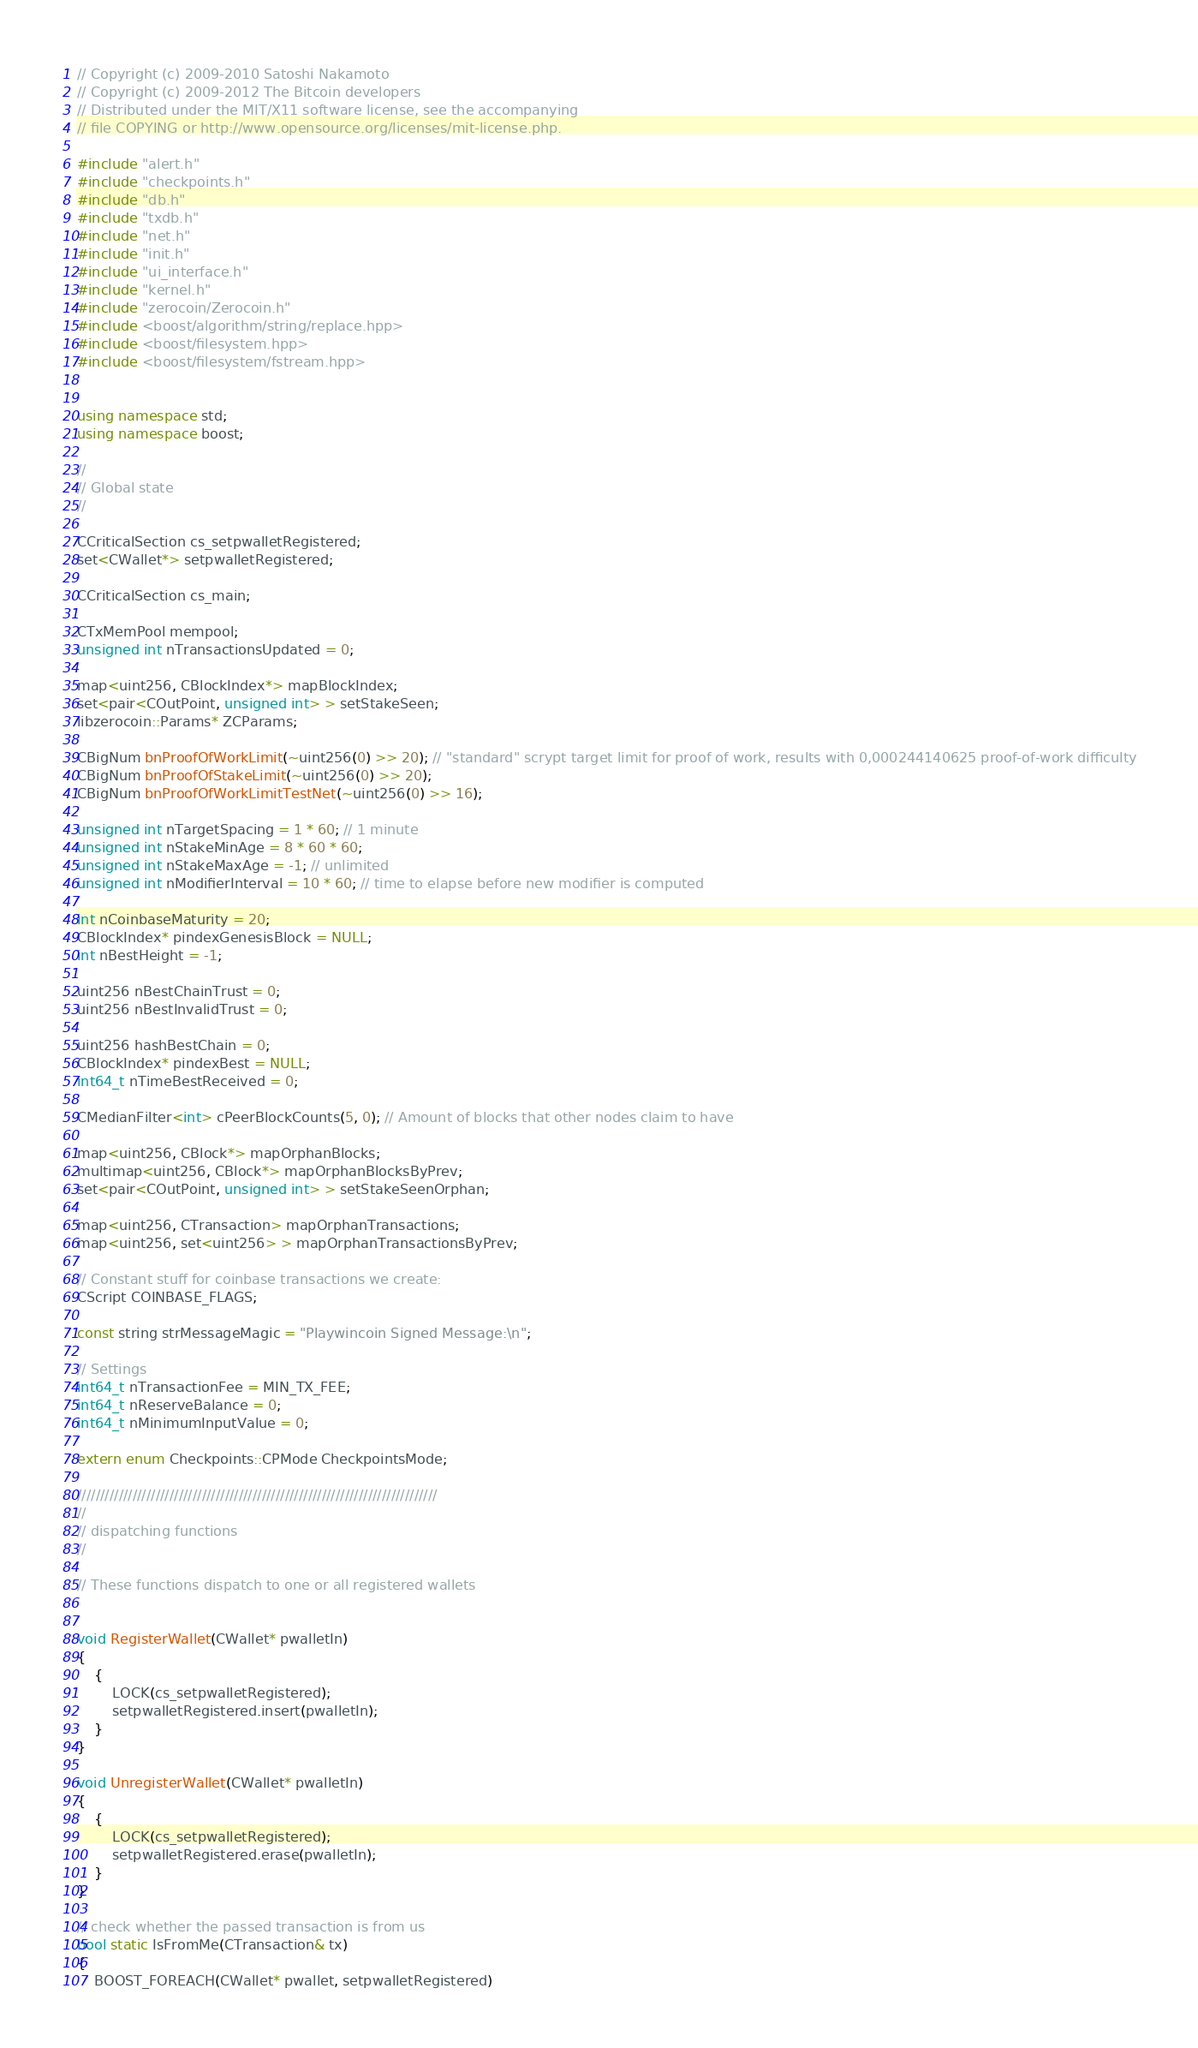Convert code to text. <code><loc_0><loc_0><loc_500><loc_500><_C++_>// Copyright (c) 2009-2010 Satoshi Nakamoto
// Copyright (c) 2009-2012 The Bitcoin developers
// Distributed under the MIT/X11 software license, see the accompanying
// file COPYING or http://www.opensource.org/licenses/mit-license.php.

#include "alert.h"
#include "checkpoints.h"
#include "db.h"
#include "txdb.h"
#include "net.h"
#include "init.h"
#include "ui_interface.h"
#include "kernel.h"
#include "zerocoin/Zerocoin.h"
#include <boost/algorithm/string/replace.hpp>
#include <boost/filesystem.hpp>
#include <boost/filesystem/fstream.hpp>


using namespace std;
using namespace boost;

//
// Global state
//

CCriticalSection cs_setpwalletRegistered;
set<CWallet*> setpwalletRegistered;

CCriticalSection cs_main;

CTxMemPool mempool;
unsigned int nTransactionsUpdated = 0;

map<uint256, CBlockIndex*> mapBlockIndex;
set<pair<COutPoint, unsigned int> > setStakeSeen;
libzerocoin::Params* ZCParams;

CBigNum bnProofOfWorkLimit(~uint256(0) >> 20); // "standard" scrypt target limit for proof of work, results with 0,000244140625 proof-of-work difficulty
CBigNum bnProofOfStakeLimit(~uint256(0) >> 20);
CBigNum bnProofOfWorkLimitTestNet(~uint256(0) >> 16);

unsigned int nTargetSpacing = 1 * 60; // 1 minute
unsigned int nStakeMinAge = 8 * 60 * 60;
unsigned int nStakeMaxAge = -1; // unlimited
unsigned int nModifierInterval = 10 * 60; // time to elapse before new modifier is computed

int nCoinbaseMaturity = 20;
CBlockIndex* pindexGenesisBlock = NULL;
int nBestHeight = -1;

uint256 nBestChainTrust = 0;
uint256 nBestInvalidTrust = 0;

uint256 hashBestChain = 0;
CBlockIndex* pindexBest = NULL;
int64_t nTimeBestReceived = 0;

CMedianFilter<int> cPeerBlockCounts(5, 0); // Amount of blocks that other nodes claim to have

map<uint256, CBlock*> mapOrphanBlocks;
multimap<uint256, CBlock*> mapOrphanBlocksByPrev;
set<pair<COutPoint, unsigned int> > setStakeSeenOrphan;

map<uint256, CTransaction> mapOrphanTransactions;
map<uint256, set<uint256> > mapOrphanTransactionsByPrev;

// Constant stuff for coinbase transactions we create:
CScript COINBASE_FLAGS;

const string strMessageMagic = "Playwincoin Signed Message:\n";

// Settings
int64_t nTransactionFee = MIN_TX_FEE;
int64_t nReserveBalance = 0;
int64_t nMinimumInputValue = 0;

extern enum Checkpoints::CPMode CheckpointsMode;

//////////////////////////////////////////////////////////////////////////////
//
// dispatching functions
//

// These functions dispatch to one or all registered wallets


void RegisterWallet(CWallet* pwalletIn)
{
    {
        LOCK(cs_setpwalletRegistered);
        setpwalletRegistered.insert(pwalletIn);
    }
}

void UnregisterWallet(CWallet* pwalletIn)
{
    {
        LOCK(cs_setpwalletRegistered);
        setpwalletRegistered.erase(pwalletIn);
    }
}

// check whether the passed transaction is from us
bool static IsFromMe(CTransaction& tx)
{
    BOOST_FOREACH(CWallet* pwallet, setpwalletRegistered)</code> 